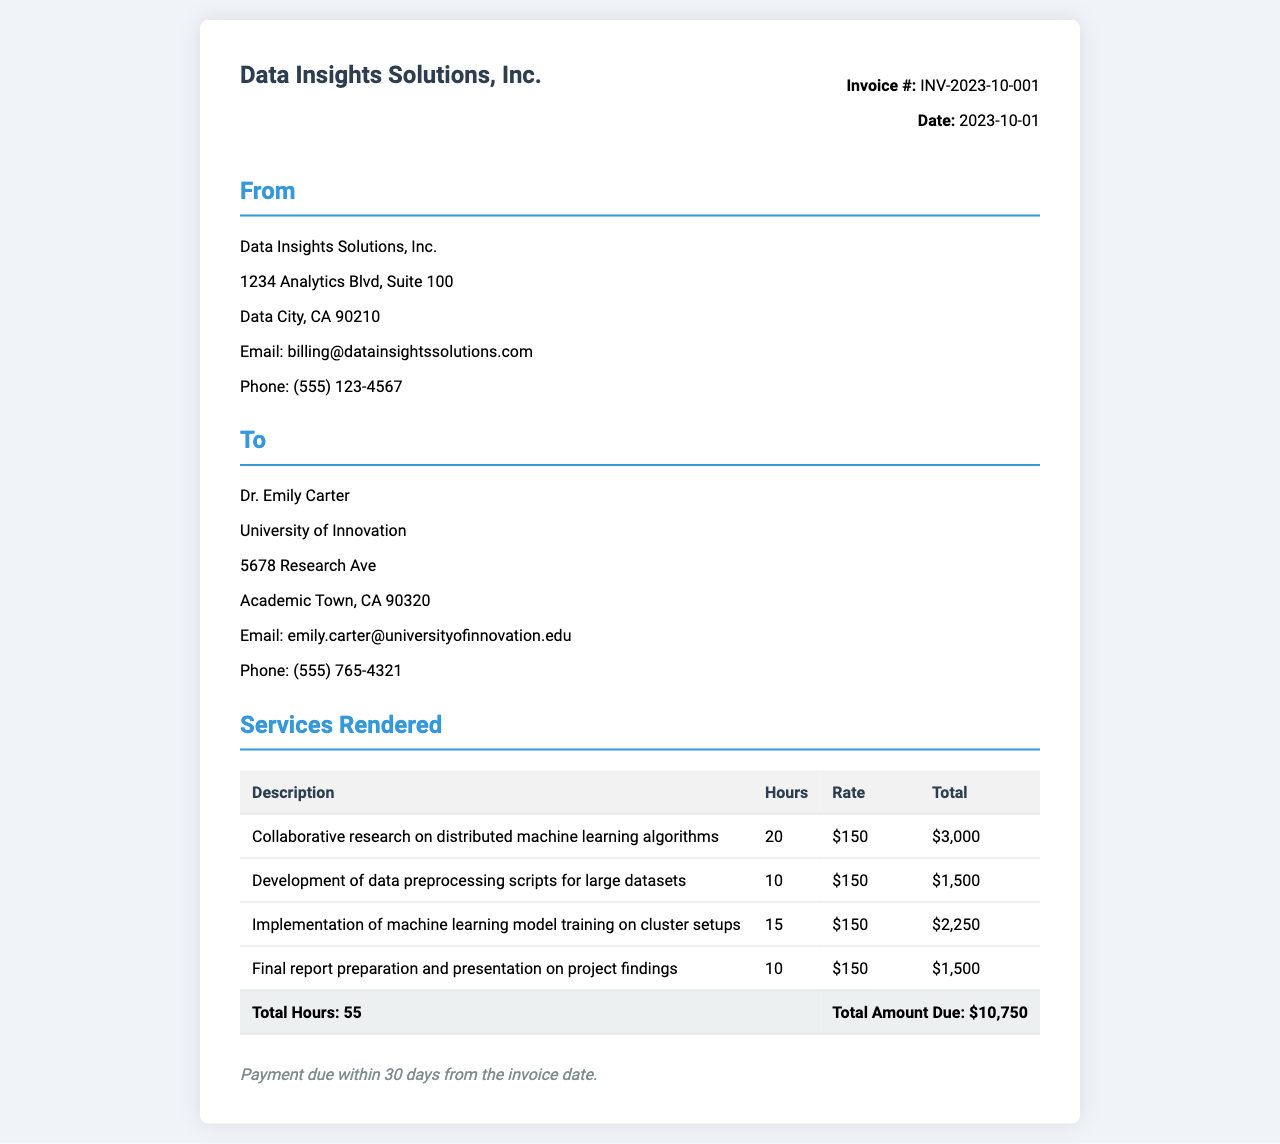What is the invoice number? The invoice number is listed in the invoice details section.
Answer: INV-2023-10-001 Who is the client? The client information is provided in the document, mentioning the name and organization.
Answer: Dr. Emily Carter What is the total amount due? The total amount due is mentioned at the end of the services rendered section.
Answer: $10,750 How many hours were spent on developing data preprocessing scripts? The hours for this specific task are provided in the services table.
Answer: 10 What is the rate per hour for the services rendered? The rate per hour is consistent across all tasks detailed in the invoice.
Answer: $150 How many total hours were worked? The total hours worked is calculated and summed up in the invoice.
Answer: 55 What is the payment term? The payment terms are specified at the bottom of the invoice.
Answer: Payment due within 30 days What service had the highest billable hours? The service with the most hours can be identified from the hours worked on each task.
Answer: Collaborative research on distributed machine learning algorithms What date was the invoice issued? The date of issuance is stated in the invoice details section.
Answer: 2023-10-01 